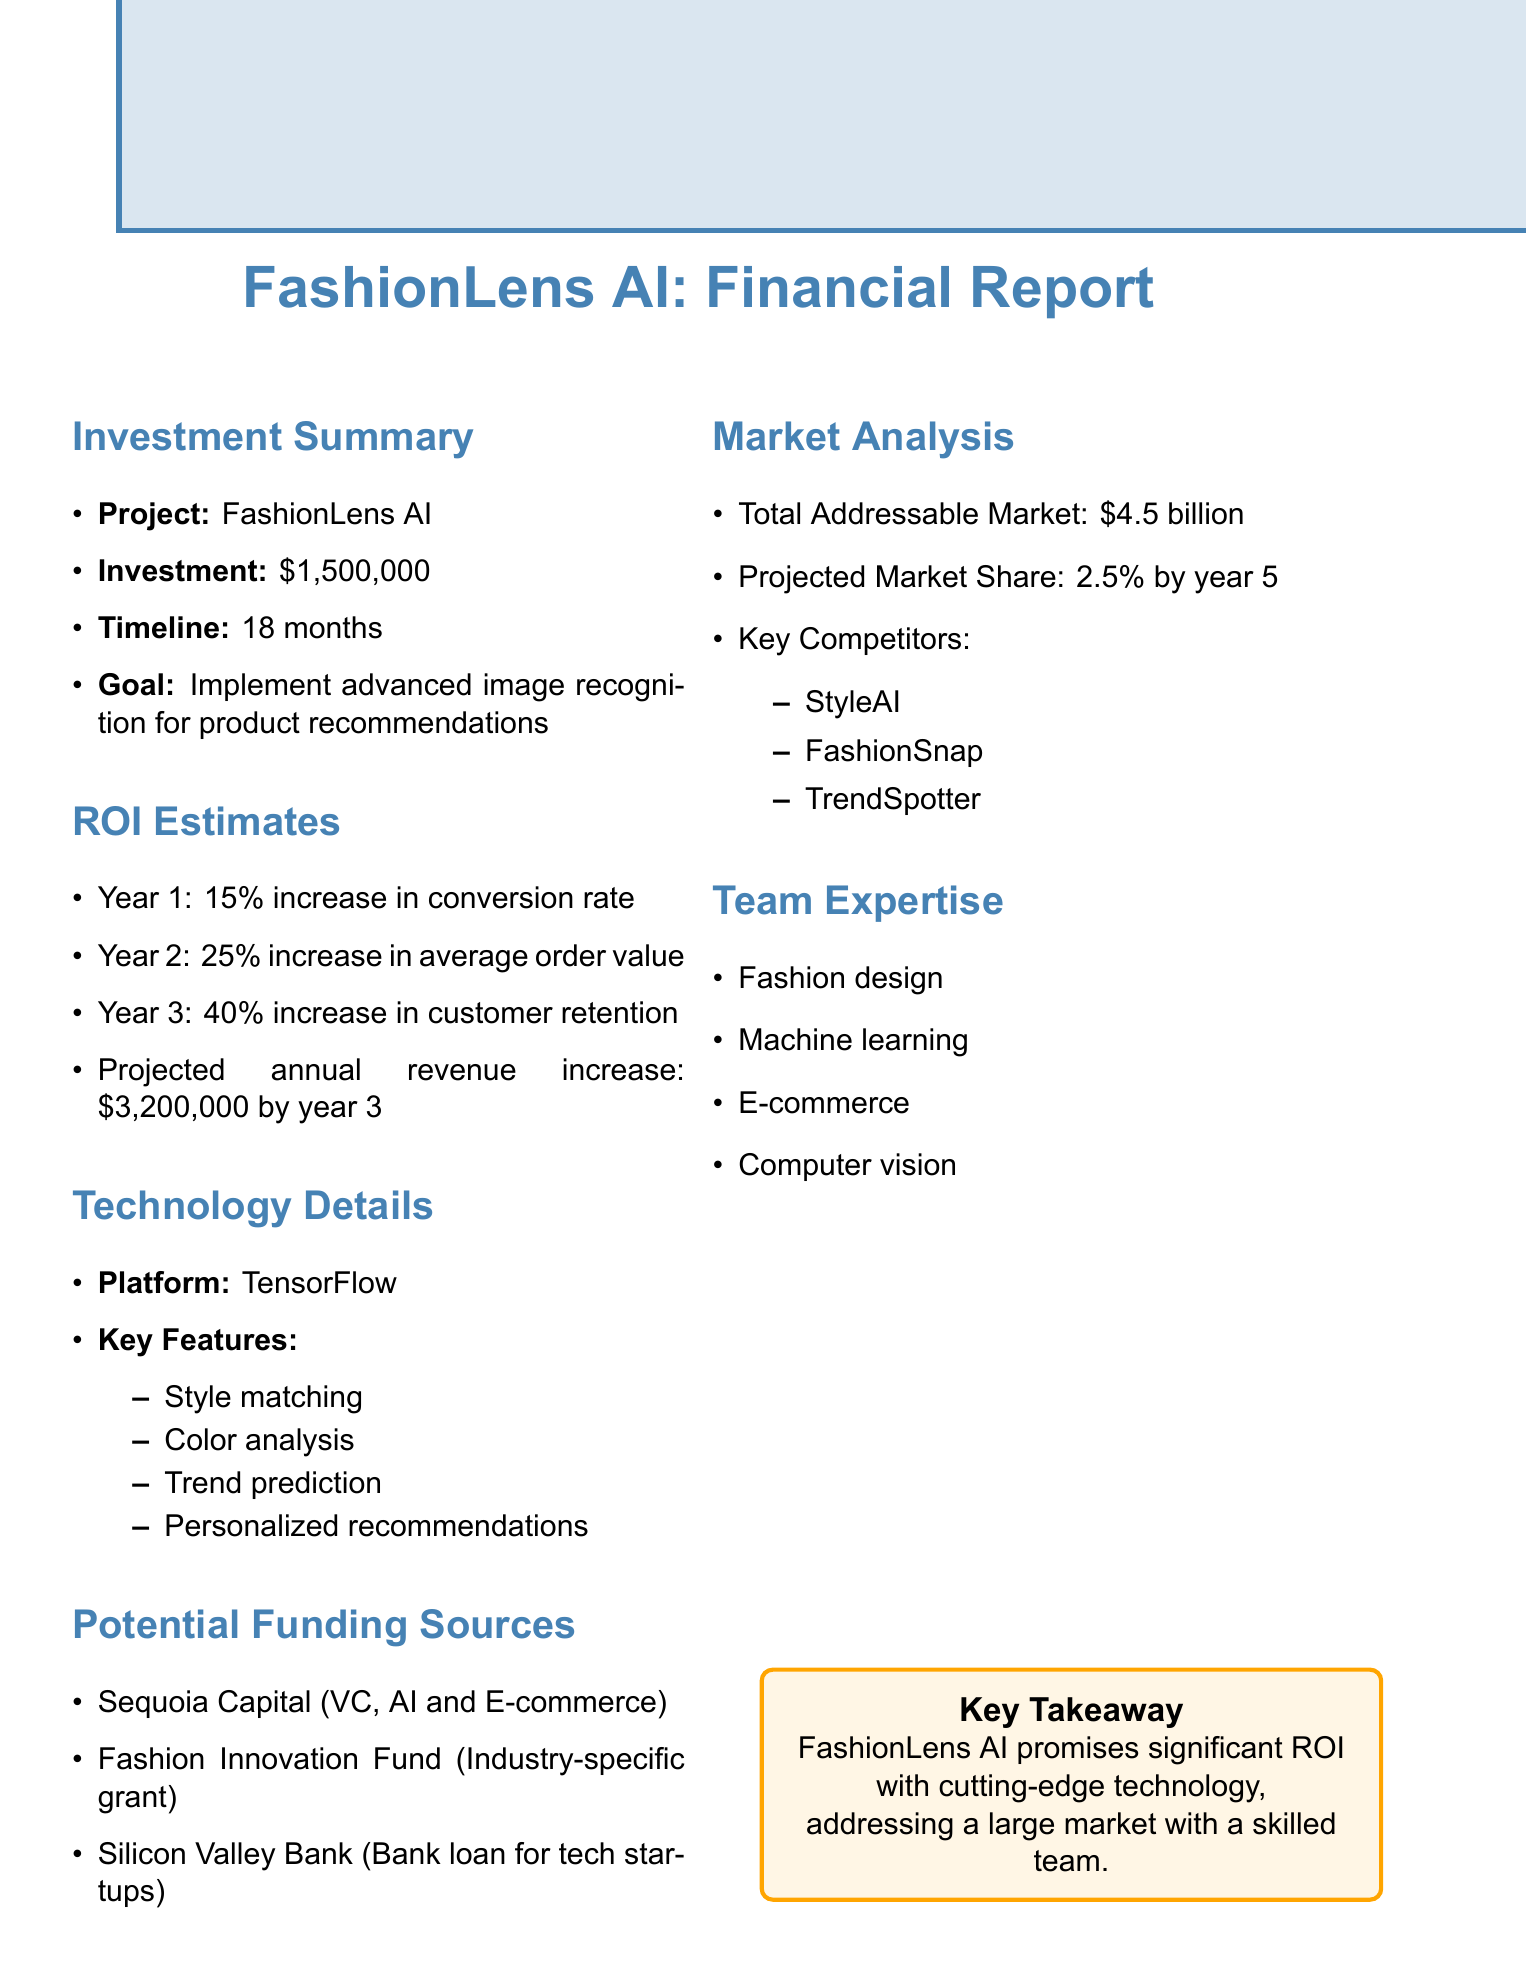what is the total investment required? The total investment required is stated explicitly in the investment summary section of the document.
Answer: $1,500,000 what is the timeline for the project? The timeline for the project is mentioned in the investment summary.
Answer: 18 months what is the platform for the technology? The platform for the technology is listed under the technology details section.
Answer: TensorFlow what is the projected annual revenue increase by year 3? The projected annual revenue increase is specified in the ROI estimates.
Answer: $3,200,000 by year 3 which venture capital firm focuses on AI and E-commerce? The potential funding sources section lists firms and their focus areas.
Answer: Sequoia Capital what is the projected market share by year 5? The projected market share is included in the market analysis section of the document.
Answer: 2.5% by year 5 which key competitor specializes in AI fashion solutions? The key competitors are listed in the market analysis section, and one of them focuses on AI in fashion.
Answer: StyleAI what is the primary goal of the project? The primary goal is mentioned in the investment summary section.
Answer: Implement advanced image recognition technology to enhance product recommendations how many key features are listed for the technology? The technology details section provides a list of features, which can be counted.
Answer: 4 